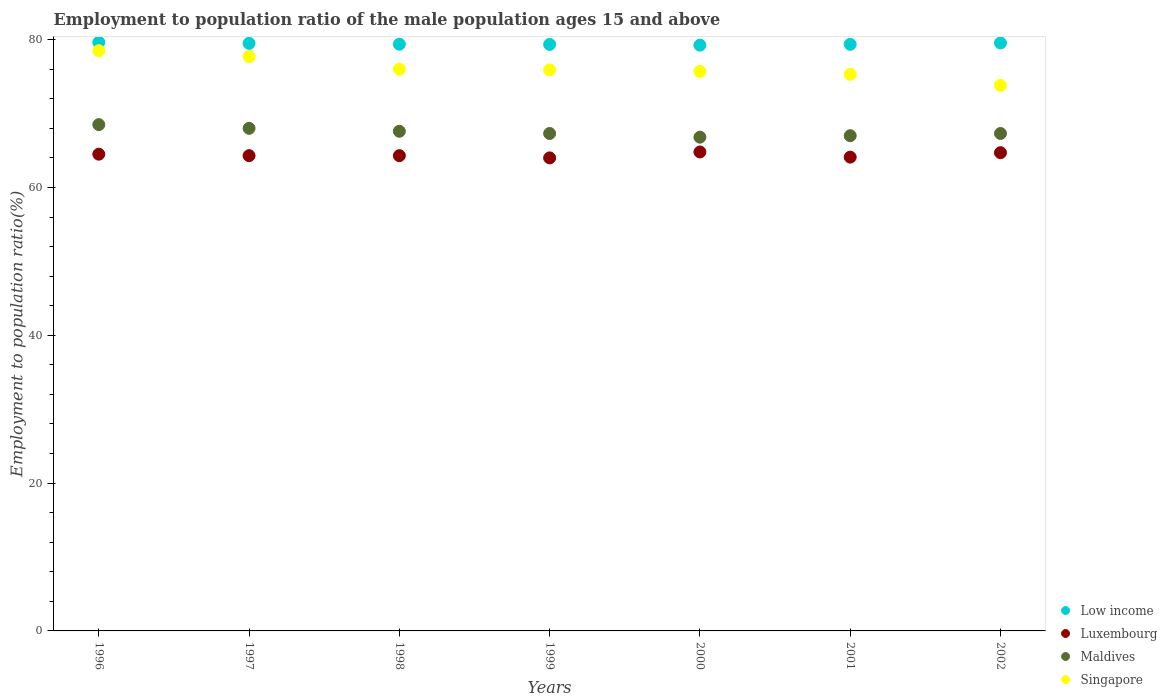How many different coloured dotlines are there?
Make the answer very short. 4. Across all years, what is the maximum employment to population ratio in Luxembourg?
Your answer should be very brief. 64.8. Across all years, what is the minimum employment to population ratio in Singapore?
Provide a short and direct response. 73.8. In which year was the employment to population ratio in Maldives maximum?
Offer a very short reply. 1996. What is the total employment to population ratio in Luxembourg in the graph?
Your answer should be very brief. 450.7. What is the difference between the employment to population ratio in Singapore in 1998 and that in 2002?
Your response must be concise. 2.2. What is the difference between the employment to population ratio in Singapore in 2002 and the employment to population ratio in Low income in 1996?
Ensure brevity in your answer.  -5.83. What is the average employment to population ratio in Low income per year?
Keep it short and to the point. 79.43. In the year 2000, what is the difference between the employment to population ratio in Singapore and employment to population ratio in Luxembourg?
Your response must be concise. 10.9. In how many years, is the employment to population ratio in Luxembourg greater than 68 %?
Ensure brevity in your answer.  0. What is the ratio of the employment to population ratio in Singapore in 1997 to that in 1998?
Your response must be concise. 1.02. Is the employment to population ratio in Low income in 1996 less than that in 1998?
Your answer should be very brief. No. Is the difference between the employment to population ratio in Singapore in 1996 and 2002 greater than the difference between the employment to population ratio in Luxembourg in 1996 and 2002?
Your answer should be very brief. Yes. What is the difference between the highest and the second highest employment to population ratio in Maldives?
Provide a short and direct response. 0.5. What is the difference between the highest and the lowest employment to population ratio in Luxembourg?
Keep it short and to the point. 0.8. Is it the case that in every year, the sum of the employment to population ratio in Luxembourg and employment to population ratio in Low income  is greater than the sum of employment to population ratio in Maldives and employment to population ratio in Singapore?
Keep it short and to the point. Yes. Is the employment to population ratio in Maldives strictly greater than the employment to population ratio in Luxembourg over the years?
Give a very brief answer. Yes. How many dotlines are there?
Ensure brevity in your answer.  4. How many years are there in the graph?
Give a very brief answer. 7. Where does the legend appear in the graph?
Offer a very short reply. Bottom right. How are the legend labels stacked?
Ensure brevity in your answer.  Vertical. What is the title of the graph?
Your response must be concise. Employment to population ratio of the male population ages 15 and above. Does "Brazil" appear as one of the legend labels in the graph?
Your response must be concise. No. What is the label or title of the X-axis?
Make the answer very short. Years. What is the label or title of the Y-axis?
Your answer should be compact. Employment to population ratio(%). What is the Employment to population ratio(%) of Low income in 1996?
Offer a very short reply. 79.63. What is the Employment to population ratio(%) of Luxembourg in 1996?
Your answer should be compact. 64.5. What is the Employment to population ratio(%) of Maldives in 1996?
Your answer should be very brief. 68.5. What is the Employment to population ratio(%) of Singapore in 1996?
Offer a very short reply. 78.5. What is the Employment to population ratio(%) of Low income in 1997?
Provide a short and direct response. 79.5. What is the Employment to population ratio(%) of Luxembourg in 1997?
Provide a succinct answer. 64.3. What is the Employment to population ratio(%) in Singapore in 1997?
Give a very brief answer. 77.7. What is the Employment to population ratio(%) in Low income in 1998?
Make the answer very short. 79.38. What is the Employment to population ratio(%) of Luxembourg in 1998?
Keep it short and to the point. 64.3. What is the Employment to population ratio(%) of Maldives in 1998?
Provide a succinct answer. 67.6. What is the Employment to population ratio(%) in Low income in 1999?
Provide a short and direct response. 79.35. What is the Employment to population ratio(%) in Maldives in 1999?
Offer a very short reply. 67.3. What is the Employment to population ratio(%) of Singapore in 1999?
Your answer should be compact. 75.9. What is the Employment to population ratio(%) in Low income in 2000?
Make the answer very short. 79.25. What is the Employment to population ratio(%) in Luxembourg in 2000?
Keep it short and to the point. 64.8. What is the Employment to population ratio(%) of Maldives in 2000?
Make the answer very short. 66.8. What is the Employment to population ratio(%) in Singapore in 2000?
Offer a very short reply. 75.7. What is the Employment to population ratio(%) of Low income in 2001?
Your answer should be very brief. 79.36. What is the Employment to population ratio(%) in Luxembourg in 2001?
Your answer should be compact. 64.1. What is the Employment to population ratio(%) in Maldives in 2001?
Give a very brief answer. 67. What is the Employment to population ratio(%) in Singapore in 2001?
Your answer should be compact. 75.3. What is the Employment to population ratio(%) of Low income in 2002?
Your answer should be compact. 79.55. What is the Employment to population ratio(%) in Luxembourg in 2002?
Offer a very short reply. 64.7. What is the Employment to population ratio(%) in Maldives in 2002?
Your answer should be very brief. 67.3. What is the Employment to population ratio(%) of Singapore in 2002?
Keep it short and to the point. 73.8. Across all years, what is the maximum Employment to population ratio(%) of Low income?
Provide a succinct answer. 79.63. Across all years, what is the maximum Employment to population ratio(%) of Luxembourg?
Offer a very short reply. 64.8. Across all years, what is the maximum Employment to population ratio(%) of Maldives?
Keep it short and to the point. 68.5. Across all years, what is the maximum Employment to population ratio(%) in Singapore?
Keep it short and to the point. 78.5. Across all years, what is the minimum Employment to population ratio(%) of Low income?
Your answer should be compact. 79.25. Across all years, what is the minimum Employment to population ratio(%) of Luxembourg?
Offer a very short reply. 64. Across all years, what is the minimum Employment to population ratio(%) in Maldives?
Offer a terse response. 66.8. Across all years, what is the minimum Employment to population ratio(%) of Singapore?
Give a very brief answer. 73.8. What is the total Employment to population ratio(%) of Low income in the graph?
Keep it short and to the point. 556.02. What is the total Employment to population ratio(%) in Luxembourg in the graph?
Your answer should be compact. 450.7. What is the total Employment to population ratio(%) of Maldives in the graph?
Offer a terse response. 472.5. What is the total Employment to population ratio(%) of Singapore in the graph?
Provide a succinct answer. 532.9. What is the difference between the Employment to population ratio(%) of Low income in 1996 and that in 1997?
Offer a terse response. 0.13. What is the difference between the Employment to population ratio(%) in Singapore in 1996 and that in 1997?
Offer a very short reply. 0.8. What is the difference between the Employment to population ratio(%) of Low income in 1996 and that in 1998?
Keep it short and to the point. 0.25. What is the difference between the Employment to population ratio(%) of Luxembourg in 1996 and that in 1998?
Your answer should be compact. 0.2. What is the difference between the Employment to population ratio(%) of Maldives in 1996 and that in 1998?
Your response must be concise. 0.9. What is the difference between the Employment to population ratio(%) of Low income in 1996 and that in 1999?
Offer a terse response. 0.28. What is the difference between the Employment to population ratio(%) of Luxembourg in 1996 and that in 1999?
Make the answer very short. 0.5. What is the difference between the Employment to population ratio(%) of Maldives in 1996 and that in 1999?
Offer a very short reply. 1.2. What is the difference between the Employment to population ratio(%) in Singapore in 1996 and that in 1999?
Your response must be concise. 2.6. What is the difference between the Employment to population ratio(%) in Low income in 1996 and that in 2000?
Keep it short and to the point. 0.38. What is the difference between the Employment to population ratio(%) in Maldives in 1996 and that in 2000?
Offer a very short reply. 1.7. What is the difference between the Employment to population ratio(%) of Low income in 1996 and that in 2001?
Your response must be concise. 0.27. What is the difference between the Employment to population ratio(%) of Luxembourg in 1996 and that in 2001?
Provide a short and direct response. 0.4. What is the difference between the Employment to population ratio(%) of Singapore in 1996 and that in 2001?
Ensure brevity in your answer.  3.2. What is the difference between the Employment to population ratio(%) of Low income in 1996 and that in 2002?
Offer a terse response. 0.08. What is the difference between the Employment to population ratio(%) in Singapore in 1996 and that in 2002?
Your answer should be very brief. 4.7. What is the difference between the Employment to population ratio(%) in Low income in 1997 and that in 1998?
Ensure brevity in your answer.  0.12. What is the difference between the Employment to population ratio(%) in Luxembourg in 1997 and that in 1998?
Your answer should be very brief. 0. What is the difference between the Employment to population ratio(%) in Maldives in 1997 and that in 1998?
Make the answer very short. 0.4. What is the difference between the Employment to population ratio(%) of Low income in 1997 and that in 1999?
Offer a terse response. 0.14. What is the difference between the Employment to population ratio(%) in Singapore in 1997 and that in 1999?
Your response must be concise. 1.8. What is the difference between the Employment to population ratio(%) of Low income in 1997 and that in 2000?
Your answer should be very brief. 0.25. What is the difference between the Employment to population ratio(%) of Maldives in 1997 and that in 2000?
Provide a succinct answer. 1.2. What is the difference between the Employment to population ratio(%) of Low income in 1997 and that in 2001?
Offer a very short reply. 0.13. What is the difference between the Employment to population ratio(%) in Luxembourg in 1997 and that in 2001?
Keep it short and to the point. 0.2. What is the difference between the Employment to population ratio(%) in Singapore in 1997 and that in 2001?
Ensure brevity in your answer.  2.4. What is the difference between the Employment to population ratio(%) in Low income in 1997 and that in 2002?
Provide a succinct answer. -0.05. What is the difference between the Employment to population ratio(%) of Luxembourg in 1997 and that in 2002?
Provide a succinct answer. -0.4. What is the difference between the Employment to population ratio(%) of Maldives in 1997 and that in 2002?
Make the answer very short. 0.7. What is the difference between the Employment to population ratio(%) in Low income in 1998 and that in 1999?
Make the answer very short. 0.03. What is the difference between the Employment to population ratio(%) in Luxembourg in 1998 and that in 1999?
Ensure brevity in your answer.  0.3. What is the difference between the Employment to population ratio(%) in Singapore in 1998 and that in 1999?
Offer a terse response. 0.1. What is the difference between the Employment to population ratio(%) in Low income in 1998 and that in 2000?
Provide a short and direct response. 0.13. What is the difference between the Employment to population ratio(%) in Luxembourg in 1998 and that in 2000?
Offer a terse response. -0.5. What is the difference between the Employment to population ratio(%) in Maldives in 1998 and that in 2000?
Your answer should be compact. 0.8. What is the difference between the Employment to population ratio(%) in Low income in 1998 and that in 2001?
Offer a very short reply. 0.02. What is the difference between the Employment to population ratio(%) of Luxembourg in 1998 and that in 2001?
Provide a succinct answer. 0.2. What is the difference between the Employment to population ratio(%) of Maldives in 1998 and that in 2001?
Your response must be concise. 0.6. What is the difference between the Employment to population ratio(%) in Singapore in 1998 and that in 2001?
Provide a succinct answer. 0.7. What is the difference between the Employment to population ratio(%) of Low income in 1998 and that in 2002?
Make the answer very short. -0.17. What is the difference between the Employment to population ratio(%) in Maldives in 1998 and that in 2002?
Provide a succinct answer. 0.3. What is the difference between the Employment to population ratio(%) of Low income in 1999 and that in 2000?
Keep it short and to the point. 0.1. What is the difference between the Employment to population ratio(%) of Low income in 1999 and that in 2001?
Offer a terse response. -0.01. What is the difference between the Employment to population ratio(%) in Luxembourg in 1999 and that in 2001?
Your answer should be very brief. -0.1. What is the difference between the Employment to population ratio(%) of Maldives in 1999 and that in 2001?
Keep it short and to the point. 0.3. What is the difference between the Employment to population ratio(%) of Singapore in 1999 and that in 2001?
Give a very brief answer. 0.6. What is the difference between the Employment to population ratio(%) in Low income in 1999 and that in 2002?
Make the answer very short. -0.2. What is the difference between the Employment to population ratio(%) in Low income in 2000 and that in 2001?
Offer a very short reply. -0.11. What is the difference between the Employment to population ratio(%) of Singapore in 2000 and that in 2001?
Your answer should be compact. 0.4. What is the difference between the Employment to population ratio(%) in Low income in 2000 and that in 2002?
Your response must be concise. -0.3. What is the difference between the Employment to population ratio(%) in Maldives in 2000 and that in 2002?
Your answer should be very brief. -0.5. What is the difference between the Employment to population ratio(%) in Singapore in 2000 and that in 2002?
Provide a succinct answer. 1.9. What is the difference between the Employment to population ratio(%) in Low income in 2001 and that in 2002?
Offer a terse response. -0.18. What is the difference between the Employment to population ratio(%) of Luxembourg in 2001 and that in 2002?
Make the answer very short. -0.6. What is the difference between the Employment to population ratio(%) in Singapore in 2001 and that in 2002?
Keep it short and to the point. 1.5. What is the difference between the Employment to population ratio(%) in Low income in 1996 and the Employment to population ratio(%) in Luxembourg in 1997?
Provide a short and direct response. 15.33. What is the difference between the Employment to population ratio(%) in Low income in 1996 and the Employment to population ratio(%) in Maldives in 1997?
Your response must be concise. 11.63. What is the difference between the Employment to population ratio(%) of Low income in 1996 and the Employment to population ratio(%) of Singapore in 1997?
Keep it short and to the point. 1.93. What is the difference between the Employment to population ratio(%) of Luxembourg in 1996 and the Employment to population ratio(%) of Singapore in 1997?
Your answer should be very brief. -13.2. What is the difference between the Employment to population ratio(%) of Maldives in 1996 and the Employment to population ratio(%) of Singapore in 1997?
Make the answer very short. -9.2. What is the difference between the Employment to population ratio(%) of Low income in 1996 and the Employment to population ratio(%) of Luxembourg in 1998?
Provide a succinct answer. 15.33. What is the difference between the Employment to population ratio(%) in Low income in 1996 and the Employment to population ratio(%) in Maldives in 1998?
Offer a very short reply. 12.03. What is the difference between the Employment to population ratio(%) of Low income in 1996 and the Employment to population ratio(%) of Singapore in 1998?
Offer a terse response. 3.63. What is the difference between the Employment to population ratio(%) in Maldives in 1996 and the Employment to population ratio(%) in Singapore in 1998?
Provide a short and direct response. -7.5. What is the difference between the Employment to population ratio(%) of Low income in 1996 and the Employment to population ratio(%) of Luxembourg in 1999?
Offer a very short reply. 15.63. What is the difference between the Employment to population ratio(%) of Low income in 1996 and the Employment to population ratio(%) of Maldives in 1999?
Provide a succinct answer. 12.33. What is the difference between the Employment to population ratio(%) in Low income in 1996 and the Employment to population ratio(%) in Singapore in 1999?
Provide a short and direct response. 3.73. What is the difference between the Employment to population ratio(%) in Luxembourg in 1996 and the Employment to population ratio(%) in Singapore in 1999?
Your answer should be very brief. -11.4. What is the difference between the Employment to population ratio(%) in Low income in 1996 and the Employment to population ratio(%) in Luxembourg in 2000?
Provide a succinct answer. 14.83. What is the difference between the Employment to population ratio(%) of Low income in 1996 and the Employment to population ratio(%) of Maldives in 2000?
Provide a succinct answer. 12.83. What is the difference between the Employment to population ratio(%) of Low income in 1996 and the Employment to population ratio(%) of Singapore in 2000?
Offer a terse response. 3.93. What is the difference between the Employment to population ratio(%) of Maldives in 1996 and the Employment to population ratio(%) of Singapore in 2000?
Keep it short and to the point. -7.2. What is the difference between the Employment to population ratio(%) in Low income in 1996 and the Employment to population ratio(%) in Luxembourg in 2001?
Your answer should be very brief. 15.53. What is the difference between the Employment to population ratio(%) in Low income in 1996 and the Employment to population ratio(%) in Maldives in 2001?
Provide a short and direct response. 12.63. What is the difference between the Employment to population ratio(%) in Low income in 1996 and the Employment to population ratio(%) in Singapore in 2001?
Provide a short and direct response. 4.33. What is the difference between the Employment to population ratio(%) of Luxembourg in 1996 and the Employment to population ratio(%) of Maldives in 2001?
Provide a succinct answer. -2.5. What is the difference between the Employment to population ratio(%) in Luxembourg in 1996 and the Employment to population ratio(%) in Singapore in 2001?
Give a very brief answer. -10.8. What is the difference between the Employment to population ratio(%) of Maldives in 1996 and the Employment to population ratio(%) of Singapore in 2001?
Your response must be concise. -6.8. What is the difference between the Employment to population ratio(%) in Low income in 1996 and the Employment to population ratio(%) in Luxembourg in 2002?
Ensure brevity in your answer.  14.93. What is the difference between the Employment to population ratio(%) of Low income in 1996 and the Employment to population ratio(%) of Maldives in 2002?
Offer a very short reply. 12.33. What is the difference between the Employment to population ratio(%) in Low income in 1996 and the Employment to population ratio(%) in Singapore in 2002?
Ensure brevity in your answer.  5.83. What is the difference between the Employment to population ratio(%) of Luxembourg in 1996 and the Employment to population ratio(%) of Singapore in 2002?
Provide a succinct answer. -9.3. What is the difference between the Employment to population ratio(%) in Maldives in 1996 and the Employment to population ratio(%) in Singapore in 2002?
Your answer should be compact. -5.3. What is the difference between the Employment to population ratio(%) of Low income in 1997 and the Employment to population ratio(%) of Luxembourg in 1998?
Offer a very short reply. 15.2. What is the difference between the Employment to population ratio(%) of Low income in 1997 and the Employment to population ratio(%) of Maldives in 1998?
Keep it short and to the point. 11.9. What is the difference between the Employment to population ratio(%) of Low income in 1997 and the Employment to population ratio(%) of Singapore in 1998?
Ensure brevity in your answer.  3.5. What is the difference between the Employment to population ratio(%) of Low income in 1997 and the Employment to population ratio(%) of Luxembourg in 1999?
Offer a terse response. 15.5. What is the difference between the Employment to population ratio(%) in Low income in 1997 and the Employment to population ratio(%) in Maldives in 1999?
Provide a succinct answer. 12.2. What is the difference between the Employment to population ratio(%) in Low income in 1997 and the Employment to population ratio(%) in Singapore in 1999?
Your answer should be compact. 3.6. What is the difference between the Employment to population ratio(%) in Luxembourg in 1997 and the Employment to population ratio(%) in Singapore in 1999?
Offer a very short reply. -11.6. What is the difference between the Employment to population ratio(%) of Maldives in 1997 and the Employment to population ratio(%) of Singapore in 1999?
Give a very brief answer. -7.9. What is the difference between the Employment to population ratio(%) of Low income in 1997 and the Employment to population ratio(%) of Luxembourg in 2000?
Make the answer very short. 14.7. What is the difference between the Employment to population ratio(%) in Low income in 1997 and the Employment to population ratio(%) in Maldives in 2000?
Ensure brevity in your answer.  12.7. What is the difference between the Employment to population ratio(%) in Low income in 1997 and the Employment to population ratio(%) in Singapore in 2000?
Keep it short and to the point. 3.8. What is the difference between the Employment to population ratio(%) of Luxembourg in 1997 and the Employment to population ratio(%) of Singapore in 2000?
Your answer should be compact. -11.4. What is the difference between the Employment to population ratio(%) in Low income in 1997 and the Employment to population ratio(%) in Luxembourg in 2001?
Keep it short and to the point. 15.4. What is the difference between the Employment to population ratio(%) in Low income in 1997 and the Employment to population ratio(%) in Maldives in 2001?
Make the answer very short. 12.5. What is the difference between the Employment to population ratio(%) in Low income in 1997 and the Employment to population ratio(%) in Singapore in 2001?
Provide a succinct answer. 4.2. What is the difference between the Employment to population ratio(%) of Luxembourg in 1997 and the Employment to population ratio(%) of Maldives in 2001?
Keep it short and to the point. -2.7. What is the difference between the Employment to population ratio(%) of Luxembourg in 1997 and the Employment to population ratio(%) of Singapore in 2001?
Offer a very short reply. -11. What is the difference between the Employment to population ratio(%) in Maldives in 1997 and the Employment to population ratio(%) in Singapore in 2001?
Keep it short and to the point. -7.3. What is the difference between the Employment to population ratio(%) in Low income in 1997 and the Employment to population ratio(%) in Luxembourg in 2002?
Offer a very short reply. 14.8. What is the difference between the Employment to population ratio(%) in Low income in 1997 and the Employment to population ratio(%) in Maldives in 2002?
Your response must be concise. 12.2. What is the difference between the Employment to population ratio(%) in Low income in 1997 and the Employment to population ratio(%) in Singapore in 2002?
Provide a succinct answer. 5.7. What is the difference between the Employment to population ratio(%) of Maldives in 1997 and the Employment to population ratio(%) of Singapore in 2002?
Keep it short and to the point. -5.8. What is the difference between the Employment to population ratio(%) of Low income in 1998 and the Employment to population ratio(%) of Luxembourg in 1999?
Give a very brief answer. 15.38. What is the difference between the Employment to population ratio(%) in Low income in 1998 and the Employment to population ratio(%) in Maldives in 1999?
Your answer should be very brief. 12.08. What is the difference between the Employment to population ratio(%) of Low income in 1998 and the Employment to population ratio(%) of Singapore in 1999?
Make the answer very short. 3.48. What is the difference between the Employment to population ratio(%) in Low income in 1998 and the Employment to population ratio(%) in Luxembourg in 2000?
Make the answer very short. 14.58. What is the difference between the Employment to population ratio(%) in Low income in 1998 and the Employment to population ratio(%) in Maldives in 2000?
Keep it short and to the point. 12.58. What is the difference between the Employment to population ratio(%) of Low income in 1998 and the Employment to population ratio(%) of Singapore in 2000?
Your answer should be very brief. 3.68. What is the difference between the Employment to population ratio(%) of Luxembourg in 1998 and the Employment to population ratio(%) of Singapore in 2000?
Provide a succinct answer. -11.4. What is the difference between the Employment to population ratio(%) in Maldives in 1998 and the Employment to population ratio(%) in Singapore in 2000?
Your answer should be compact. -8.1. What is the difference between the Employment to population ratio(%) of Low income in 1998 and the Employment to population ratio(%) of Luxembourg in 2001?
Offer a terse response. 15.28. What is the difference between the Employment to population ratio(%) of Low income in 1998 and the Employment to population ratio(%) of Maldives in 2001?
Keep it short and to the point. 12.38. What is the difference between the Employment to population ratio(%) of Low income in 1998 and the Employment to population ratio(%) of Singapore in 2001?
Your answer should be compact. 4.08. What is the difference between the Employment to population ratio(%) of Luxembourg in 1998 and the Employment to population ratio(%) of Singapore in 2001?
Offer a very short reply. -11. What is the difference between the Employment to population ratio(%) in Low income in 1998 and the Employment to population ratio(%) in Luxembourg in 2002?
Give a very brief answer. 14.68. What is the difference between the Employment to population ratio(%) in Low income in 1998 and the Employment to population ratio(%) in Maldives in 2002?
Keep it short and to the point. 12.08. What is the difference between the Employment to population ratio(%) of Low income in 1998 and the Employment to population ratio(%) of Singapore in 2002?
Your answer should be very brief. 5.58. What is the difference between the Employment to population ratio(%) of Luxembourg in 1998 and the Employment to population ratio(%) of Singapore in 2002?
Provide a succinct answer. -9.5. What is the difference between the Employment to population ratio(%) in Low income in 1999 and the Employment to population ratio(%) in Luxembourg in 2000?
Keep it short and to the point. 14.55. What is the difference between the Employment to population ratio(%) of Low income in 1999 and the Employment to population ratio(%) of Maldives in 2000?
Give a very brief answer. 12.55. What is the difference between the Employment to population ratio(%) in Low income in 1999 and the Employment to population ratio(%) in Singapore in 2000?
Give a very brief answer. 3.65. What is the difference between the Employment to population ratio(%) of Maldives in 1999 and the Employment to population ratio(%) of Singapore in 2000?
Provide a short and direct response. -8.4. What is the difference between the Employment to population ratio(%) of Low income in 1999 and the Employment to population ratio(%) of Luxembourg in 2001?
Offer a terse response. 15.25. What is the difference between the Employment to population ratio(%) in Low income in 1999 and the Employment to population ratio(%) in Maldives in 2001?
Ensure brevity in your answer.  12.35. What is the difference between the Employment to population ratio(%) of Low income in 1999 and the Employment to population ratio(%) of Singapore in 2001?
Provide a succinct answer. 4.05. What is the difference between the Employment to population ratio(%) of Luxembourg in 1999 and the Employment to population ratio(%) of Singapore in 2001?
Offer a very short reply. -11.3. What is the difference between the Employment to population ratio(%) in Maldives in 1999 and the Employment to population ratio(%) in Singapore in 2001?
Offer a terse response. -8. What is the difference between the Employment to population ratio(%) in Low income in 1999 and the Employment to population ratio(%) in Luxembourg in 2002?
Keep it short and to the point. 14.65. What is the difference between the Employment to population ratio(%) of Low income in 1999 and the Employment to population ratio(%) of Maldives in 2002?
Your response must be concise. 12.05. What is the difference between the Employment to population ratio(%) in Low income in 1999 and the Employment to population ratio(%) in Singapore in 2002?
Offer a terse response. 5.55. What is the difference between the Employment to population ratio(%) in Luxembourg in 1999 and the Employment to population ratio(%) in Singapore in 2002?
Make the answer very short. -9.8. What is the difference between the Employment to population ratio(%) in Low income in 2000 and the Employment to population ratio(%) in Luxembourg in 2001?
Provide a succinct answer. 15.15. What is the difference between the Employment to population ratio(%) of Low income in 2000 and the Employment to population ratio(%) of Maldives in 2001?
Offer a very short reply. 12.25. What is the difference between the Employment to population ratio(%) in Low income in 2000 and the Employment to population ratio(%) in Singapore in 2001?
Your answer should be compact. 3.95. What is the difference between the Employment to population ratio(%) of Luxembourg in 2000 and the Employment to population ratio(%) of Singapore in 2001?
Your answer should be very brief. -10.5. What is the difference between the Employment to population ratio(%) of Maldives in 2000 and the Employment to population ratio(%) of Singapore in 2001?
Ensure brevity in your answer.  -8.5. What is the difference between the Employment to population ratio(%) of Low income in 2000 and the Employment to population ratio(%) of Luxembourg in 2002?
Ensure brevity in your answer.  14.55. What is the difference between the Employment to population ratio(%) in Low income in 2000 and the Employment to population ratio(%) in Maldives in 2002?
Offer a very short reply. 11.95. What is the difference between the Employment to population ratio(%) in Low income in 2000 and the Employment to population ratio(%) in Singapore in 2002?
Keep it short and to the point. 5.45. What is the difference between the Employment to population ratio(%) in Luxembourg in 2000 and the Employment to population ratio(%) in Singapore in 2002?
Give a very brief answer. -9. What is the difference between the Employment to population ratio(%) in Low income in 2001 and the Employment to population ratio(%) in Luxembourg in 2002?
Ensure brevity in your answer.  14.66. What is the difference between the Employment to population ratio(%) of Low income in 2001 and the Employment to population ratio(%) of Maldives in 2002?
Make the answer very short. 12.06. What is the difference between the Employment to population ratio(%) in Low income in 2001 and the Employment to population ratio(%) in Singapore in 2002?
Make the answer very short. 5.56. What is the difference between the Employment to population ratio(%) of Luxembourg in 2001 and the Employment to population ratio(%) of Maldives in 2002?
Provide a succinct answer. -3.2. What is the difference between the Employment to population ratio(%) of Maldives in 2001 and the Employment to population ratio(%) of Singapore in 2002?
Your answer should be compact. -6.8. What is the average Employment to population ratio(%) in Low income per year?
Keep it short and to the point. 79.43. What is the average Employment to population ratio(%) in Luxembourg per year?
Ensure brevity in your answer.  64.39. What is the average Employment to population ratio(%) of Maldives per year?
Your answer should be compact. 67.5. What is the average Employment to population ratio(%) of Singapore per year?
Your answer should be very brief. 76.13. In the year 1996, what is the difference between the Employment to population ratio(%) in Low income and Employment to population ratio(%) in Luxembourg?
Offer a very short reply. 15.13. In the year 1996, what is the difference between the Employment to population ratio(%) of Low income and Employment to population ratio(%) of Maldives?
Keep it short and to the point. 11.13. In the year 1996, what is the difference between the Employment to population ratio(%) in Low income and Employment to population ratio(%) in Singapore?
Offer a terse response. 1.13. In the year 1996, what is the difference between the Employment to population ratio(%) of Luxembourg and Employment to population ratio(%) of Maldives?
Offer a very short reply. -4. In the year 1996, what is the difference between the Employment to population ratio(%) of Luxembourg and Employment to population ratio(%) of Singapore?
Your response must be concise. -14. In the year 1996, what is the difference between the Employment to population ratio(%) of Maldives and Employment to population ratio(%) of Singapore?
Your answer should be very brief. -10. In the year 1997, what is the difference between the Employment to population ratio(%) in Low income and Employment to population ratio(%) in Luxembourg?
Provide a succinct answer. 15.2. In the year 1997, what is the difference between the Employment to population ratio(%) of Low income and Employment to population ratio(%) of Maldives?
Your answer should be very brief. 11.5. In the year 1997, what is the difference between the Employment to population ratio(%) in Low income and Employment to population ratio(%) in Singapore?
Provide a succinct answer. 1.8. In the year 1997, what is the difference between the Employment to population ratio(%) in Maldives and Employment to population ratio(%) in Singapore?
Keep it short and to the point. -9.7. In the year 1998, what is the difference between the Employment to population ratio(%) in Low income and Employment to population ratio(%) in Luxembourg?
Your answer should be compact. 15.08. In the year 1998, what is the difference between the Employment to population ratio(%) of Low income and Employment to population ratio(%) of Maldives?
Provide a succinct answer. 11.78. In the year 1998, what is the difference between the Employment to population ratio(%) of Low income and Employment to population ratio(%) of Singapore?
Your response must be concise. 3.38. In the year 1998, what is the difference between the Employment to population ratio(%) of Maldives and Employment to population ratio(%) of Singapore?
Offer a terse response. -8.4. In the year 1999, what is the difference between the Employment to population ratio(%) of Low income and Employment to population ratio(%) of Luxembourg?
Your response must be concise. 15.35. In the year 1999, what is the difference between the Employment to population ratio(%) of Low income and Employment to population ratio(%) of Maldives?
Ensure brevity in your answer.  12.05. In the year 1999, what is the difference between the Employment to population ratio(%) in Low income and Employment to population ratio(%) in Singapore?
Keep it short and to the point. 3.45. In the year 1999, what is the difference between the Employment to population ratio(%) in Luxembourg and Employment to population ratio(%) in Maldives?
Make the answer very short. -3.3. In the year 1999, what is the difference between the Employment to population ratio(%) in Luxembourg and Employment to population ratio(%) in Singapore?
Your answer should be compact. -11.9. In the year 1999, what is the difference between the Employment to population ratio(%) of Maldives and Employment to population ratio(%) of Singapore?
Give a very brief answer. -8.6. In the year 2000, what is the difference between the Employment to population ratio(%) in Low income and Employment to population ratio(%) in Luxembourg?
Offer a terse response. 14.45. In the year 2000, what is the difference between the Employment to population ratio(%) in Low income and Employment to population ratio(%) in Maldives?
Give a very brief answer. 12.45. In the year 2000, what is the difference between the Employment to population ratio(%) of Low income and Employment to population ratio(%) of Singapore?
Provide a short and direct response. 3.55. In the year 2000, what is the difference between the Employment to population ratio(%) in Luxembourg and Employment to population ratio(%) in Maldives?
Your answer should be very brief. -2. In the year 2000, what is the difference between the Employment to population ratio(%) in Luxembourg and Employment to population ratio(%) in Singapore?
Provide a succinct answer. -10.9. In the year 2001, what is the difference between the Employment to population ratio(%) of Low income and Employment to population ratio(%) of Luxembourg?
Provide a succinct answer. 15.26. In the year 2001, what is the difference between the Employment to population ratio(%) of Low income and Employment to population ratio(%) of Maldives?
Your answer should be very brief. 12.36. In the year 2001, what is the difference between the Employment to population ratio(%) of Low income and Employment to population ratio(%) of Singapore?
Offer a very short reply. 4.06. In the year 2001, what is the difference between the Employment to population ratio(%) of Maldives and Employment to population ratio(%) of Singapore?
Give a very brief answer. -8.3. In the year 2002, what is the difference between the Employment to population ratio(%) of Low income and Employment to population ratio(%) of Luxembourg?
Offer a very short reply. 14.85. In the year 2002, what is the difference between the Employment to population ratio(%) of Low income and Employment to population ratio(%) of Maldives?
Your response must be concise. 12.25. In the year 2002, what is the difference between the Employment to population ratio(%) of Low income and Employment to population ratio(%) of Singapore?
Your answer should be very brief. 5.75. In the year 2002, what is the difference between the Employment to population ratio(%) of Luxembourg and Employment to population ratio(%) of Singapore?
Offer a very short reply. -9.1. What is the ratio of the Employment to population ratio(%) of Low income in 1996 to that in 1997?
Your response must be concise. 1. What is the ratio of the Employment to population ratio(%) of Luxembourg in 1996 to that in 1997?
Your answer should be very brief. 1. What is the ratio of the Employment to population ratio(%) in Maldives in 1996 to that in 1997?
Offer a very short reply. 1.01. What is the ratio of the Employment to population ratio(%) of Singapore in 1996 to that in 1997?
Keep it short and to the point. 1.01. What is the ratio of the Employment to population ratio(%) of Luxembourg in 1996 to that in 1998?
Ensure brevity in your answer.  1. What is the ratio of the Employment to population ratio(%) in Maldives in 1996 to that in 1998?
Offer a very short reply. 1.01. What is the ratio of the Employment to population ratio(%) in Singapore in 1996 to that in 1998?
Keep it short and to the point. 1.03. What is the ratio of the Employment to population ratio(%) in Maldives in 1996 to that in 1999?
Your answer should be very brief. 1.02. What is the ratio of the Employment to population ratio(%) in Singapore in 1996 to that in 1999?
Offer a terse response. 1.03. What is the ratio of the Employment to population ratio(%) of Luxembourg in 1996 to that in 2000?
Your answer should be very brief. 1. What is the ratio of the Employment to population ratio(%) of Maldives in 1996 to that in 2000?
Your answer should be compact. 1.03. What is the ratio of the Employment to population ratio(%) in Singapore in 1996 to that in 2000?
Offer a very short reply. 1.04. What is the ratio of the Employment to population ratio(%) in Luxembourg in 1996 to that in 2001?
Provide a short and direct response. 1.01. What is the ratio of the Employment to population ratio(%) of Maldives in 1996 to that in 2001?
Make the answer very short. 1.02. What is the ratio of the Employment to population ratio(%) of Singapore in 1996 to that in 2001?
Keep it short and to the point. 1.04. What is the ratio of the Employment to population ratio(%) of Maldives in 1996 to that in 2002?
Provide a succinct answer. 1.02. What is the ratio of the Employment to population ratio(%) in Singapore in 1996 to that in 2002?
Give a very brief answer. 1.06. What is the ratio of the Employment to population ratio(%) of Luxembourg in 1997 to that in 1998?
Your answer should be compact. 1. What is the ratio of the Employment to population ratio(%) of Maldives in 1997 to that in 1998?
Your response must be concise. 1.01. What is the ratio of the Employment to population ratio(%) of Singapore in 1997 to that in 1998?
Your answer should be very brief. 1.02. What is the ratio of the Employment to population ratio(%) of Luxembourg in 1997 to that in 1999?
Ensure brevity in your answer.  1. What is the ratio of the Employment to population ratio(%) in Maldives in 1997 to that in 1999?
Your response must be concise. 1.01. What is the ratio of the Employment to population ratio(%) of Singapore in 1997 to that in 1999?
Your answer should be compact. 1.02. What is the ratio of the Employment to population ratio(%) in Low income in 1997 to that in 2000?
Offer a very short reply. 1. What is the ratio of the Employment to population ratio(%) of Luxembourg in 1997 to that in 2000?
Offer a very short reply. 0.99. What is the ratio of the Employment to population ratio(%) in Maldives in 1997 to that in 2000?
Provide a short and direct response. 1.02. What is the ratio of the Employment to population ratio(%) of Singapore in 1997 to that in 2000?
Ensure brevity in your answer.  1.03. What is the ratio of the Employment to population ratio(%) of Maldives in 1997 to that in 2001?
Offer a very short reply. 1.01. What is the ratio of the Employment to population ratio(%) in Singapore in 1997 to that in 2001?
Your response must be concise. 1.03. What is the ratio of the Employment to population ratio(%) of Luxembourg in 1997 to that in 2002?
Offer a very short reply. 0.99. What is the ratio of the Employment to population ratio(%) in Maldives in 1997 to that in 2002?
Provide a succinct answer. 1.01. What is the ratio of the Employment to population ratio(%) of Singapore in 1997 to that in 2002?
Offer a very short reply. 1.05. What is the ratio of the Employment to population ratio(%) in Low income in 1998 to that in 1999?
Give a very brief answer. 1. What is the ratio of the Employment to population ratio(%) of Maldives in 1998 to that in 1999?
Your answer should be very brief. 1. What is the ratio of the Employment to population ratio(%) in Singapore in 1998 to that in 1999?
Make the answer very short. 1. What is the ratio of the Employment to population ratio(%) in Luxembourg in 1998 to that in 2000?
Your response must be concise. 0.99. What is the ratio of the Employment to population ratio(%) of Low income in 1998 to that in 2001?
Make the answer very short. 1. What is the ratio of the Employment to population ratio(%) of Luxembourg in 1998 to that in 2001?
Offer a terse response. 1. What is the ratio of the Employment to population ratio(%) in Singapore in 1998 to that in 2001?
Make the answer very short. 1.01. What is the ratio of the Employment to population ratio(%) of Low income in 1998 to that in 2002?
Offer a very short reply. 1. What is the ratio of the Employment to population ratio(%) of Luxembourg in 1998 to that in 2002?
Your response must be concise. 0.99. What is the ratio of the Employment to population ratio(%) of Singapore in 1998 to that in 2002?
Your answer should be very brief. 1.03. What is the ratio of the Employment to population ratio(%) in Low income in 1999 to that in 2000?
Provide a succinct answer. 1. What is the ratio of the Employment to population ratio(%) in Maldives in 1999 to that in 2000?
Offer a terse response. 1.01. What is the ratio of the Employment to population ratio(%) in Singapore in 1999 to that in 2000?
Ensure brevity in your answer.  1. What is the ratio of the Employment to population ratio(%) in Low income in 1999 to that in 2001?
Ensure brevity in your answer.  1. What is the ratio of the Employment to population ratio(%) of Low income in 1999 to that in 2002?
Your answer should be compact. 1. What is the ratio of the Employment to population ratio(%) of Luxembourg in 1999 to that in 2002?
Provide a short and direct response. 0.99. What is the ratio of the Employment to population ratio(%) of Maldives in 1999 to that in 2002?
Your response must be concise. 1. What is the ratio of the Employment to population ratio(%) of Singapore in 1999 to that in 2002?
Offer a very short reply. 1.03. What is the ratio of the Employment to population ratio(%) in Luxembourg in 2000 to that in 2001?
Give a very brief answer. 1.01. What is the ratio of the Employment to population ratio(%) of Luxembourg in 2000 to that in 2002?
Provide a short and direct response. 1. What is the ratio of the Employment to population ratio(%) of Maldives in 2000 to that in 2002?
Offer a very short reply. 0.99. What is the ratio of the Employment to population ratio(%) in Singapore in 2000 to that in 2002?
Your response must be concise. 1.03. What is the ratio of the Employment to population ratio(%) in Low income in 2001 to that in 2002?
Provide a succinct answer. 1. What is the ratio of the Employment to population ratio(%) in Luxembourg in 2001 to that in 2002?
Your answer should be compact. 0.99. What is the ratio of the Employment to population ratio(%) in Singapore in 2001 to that in 2002?
Provide a succinct answer. 1.02. What is the difference between the highest and the second highest Employment to population ratio(%) in Low income?
Your answer should be compact. 0.08. What is the difference between the highest and the second highest Employment to population ratio(%) of Maldives?
Make the answer very short. 0.5. What is the difference between the highest and the second highest Employment to population ratio(%) of Singapore?
Provide a short and direct response. 0.8. What is the difference between the highest and the lowest Employment to population ratio(%) in Low income?
Offer a terse response. 0.38. What is the difference between the highest and the lowest Employment to population ratio(%) of Luxembourg?
Your answer should be very brief. 0.8. What is the difference between the highest and the lowest Employment to population ratio(%) in Maldives?
Give a very brief answer. 1.7. What is the difference between the highest and the lowest Employment to population ratio(%) of Singapore?
Your response must be concise. 4.7. 